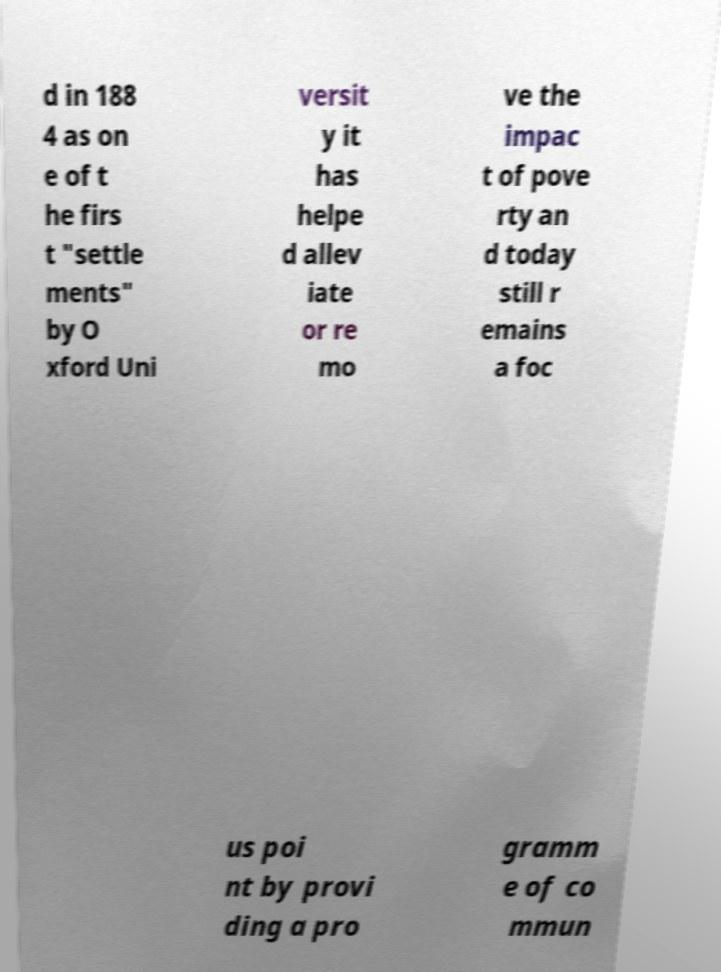Please identify and transcribe the text found in this image. d in 188 4 as on e of t he firs t "settle ments" by O xford Uni versit y it has helpe d allev iate or re mo ve the impac t of pove rty an d today still r emains a foc us poi nt by provi ding a pro gramm e of co mmun 